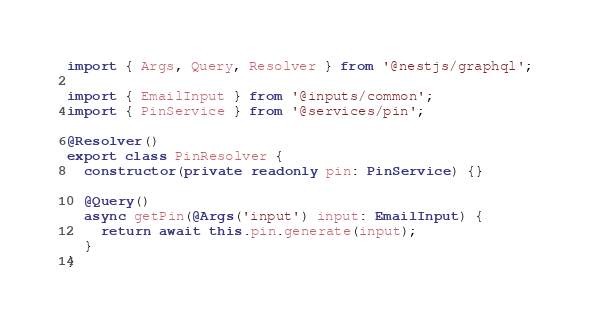<code> <loc_0><loc_0><loc_500><loc_500><_TypeScript_>import { Args, Query, Resolver } from '@nestjs/graphql';

import { EmailInput } from '@inputs/common';
import { PinService } from '@services/pin';

@Resolver()
export class PinResolver {
  constructor(private readonly pin: PinService) {}

  @Query()
  async getPin(@Args('input') input: EmailInput) {
    return await this.pin.generate(input);
  }
}
</code> 